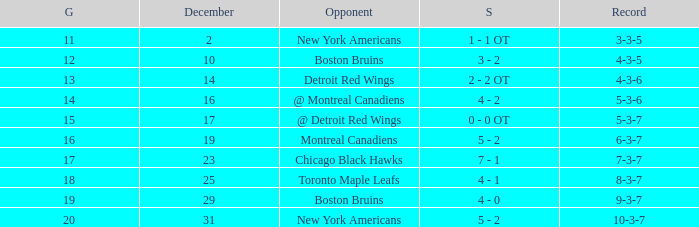Which Score has a December smaller than 14, and a Game of 12? 3 - 2. 